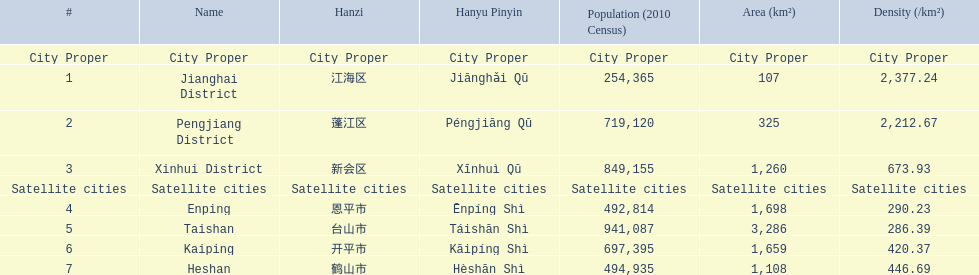What are all the municipalities? Jianghai District, Pengjiang District, Xinhui District, Enping, Taishan, Kaiping, Heshan. Among them, which are considered satellite cities? Enping, Taishan, Kaiping, Heshan. For these, what are their population sizes? 492,814, 941,087, 697,395, 494,935. Out of these, which is the most populous? 941,087. Which city has this population? Taishan. 